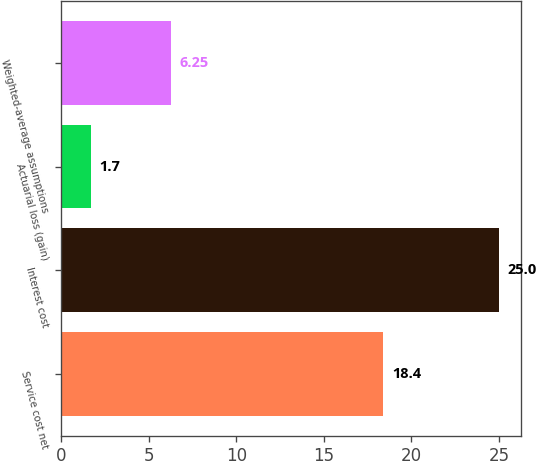Convert chart. <chart><loc_0><loc_0><loc_500><loc_500><bar_chart><fcel>Service cost net<fcel>Interest cost<fcel>Actuarial loss (gain)<fcel>Weighted-average assumptions<nl><fcel>18.4<fcel>25<fcel>1.7<fcel>6.25<nl></chart> 